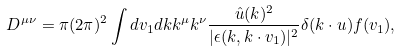Convert formula to latex. <formula><loc_0><loc_0><loc_500><loc_500>D ^ { \mu \nu } = \pi ( 2 \pi ) ^ { 2 } \int d { v } _ { 1 } d { k } k ^ { \mu } k ^ { \nu } \frac { \hat { u } ( k ) ^ { 2 } } { | \epsilon ( { k } , { k } \cdot { v } _ { 1 } ) | ^ { 2 } } \delta ( { k } \cdot { u } ) f ( { v } _ { 1 } ) ,</formula> 